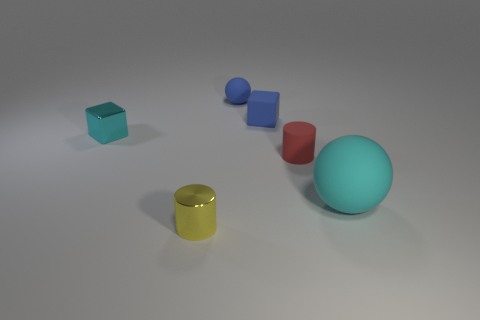Subtract all blue spheres. How many spheres are left? 1 Add 4 cyan spheres. How many objects exist? 10 Subtract all spheres. How many objects are left? 4 Subtract 0 green cylinders. How many objects are left? 6 Subtract all brown spheres. Subtract all green cylinders. How many spheres are left? 2 Subtract all small red things. Subtract all small gray rubber balls. How many objects are left? 5 Add 3 blue matte spheres. How many blue matte spheres are left? 4 Add 4 tiny gray cylinders. How many tiny gray cylinders exist? 4 